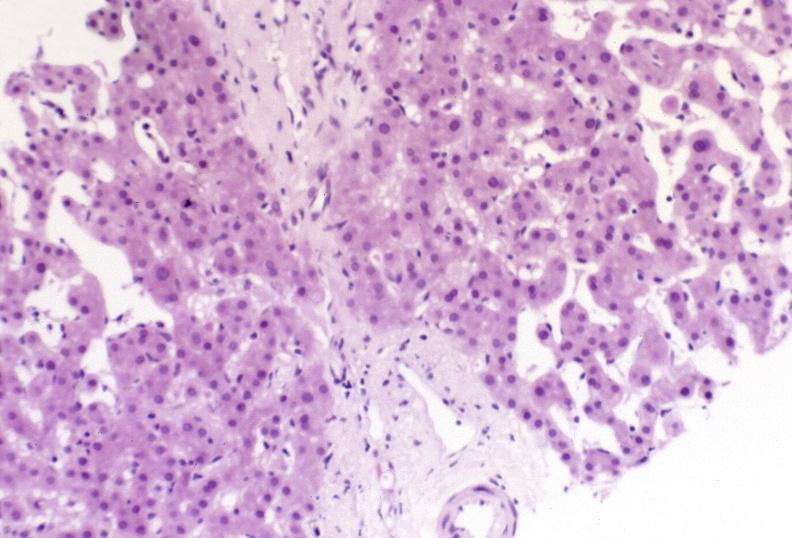what is present?
Answer the question using a single word or phrase. Hepatobiliary 